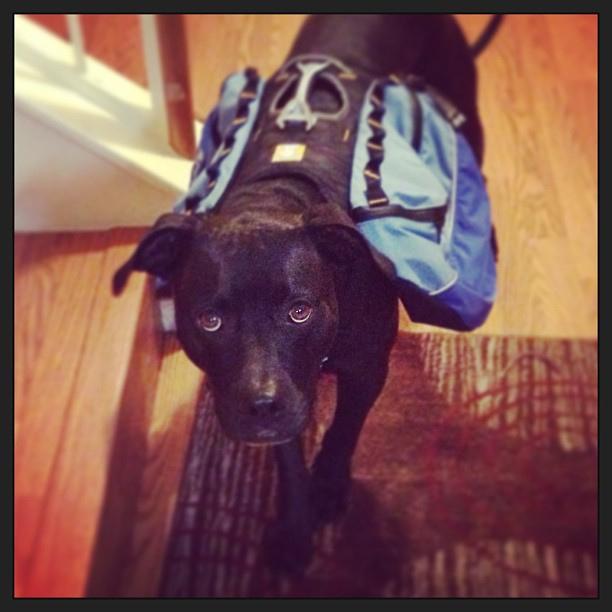What is the dog looking at?
Answer briefly. Camera. Is it the right or left paw that this dog has in front of the other?
Write a very short answer. Right. Does the rug on the floor cover the whole floor?
Answer briefly. No. 